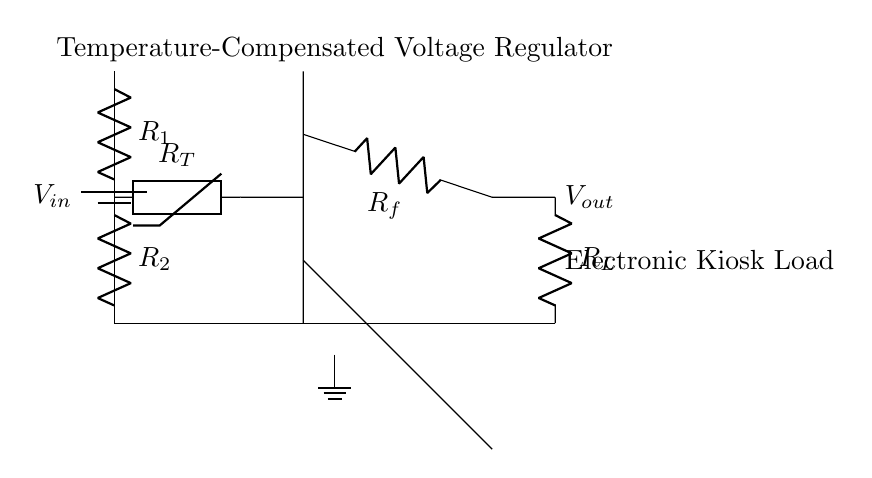What is the power supply voltage in this circuit? The power supply voltage is indicated as \( V_{in} \) at the top of the battery symbol in the circuit diagram.
Answer: \( V_{in} \) What type of resistor is used to sense temperature? The temperature-sensitive resistor is labeled as \( R_T \) in the circuit diagram, indicating that it is a thermistor.
Answer: thermistor How many resistors are in the voltage divider? There are two resistors in the voltage divider section, labeled \( R_1 \) and \( R_2 \), connected in series.
Answer: 2 What is the role of the operational amplifier in this circuit? The operational amplifier, shown in the circuit as an op amp, is used for signal conditioning and to regulate the output voltage based on the voltage from the temperature sensor.
Answer: Voltage regulation What happens to the output voltage when the temperature increases? When the temperature increases, the resistance of the thermistor decreases, which affects the feedback to the op amp, causing it to adjust the output voltage \( V_{out} \) to maintain stability.
Answer: increases What is the load connected to \( V_{out} \)? The load connected to \( V_{out} \) is labeled \( R_L \) in the circuit, indicating that it represents the electronic kiosk load.
Answer: Electronic kiosk load 